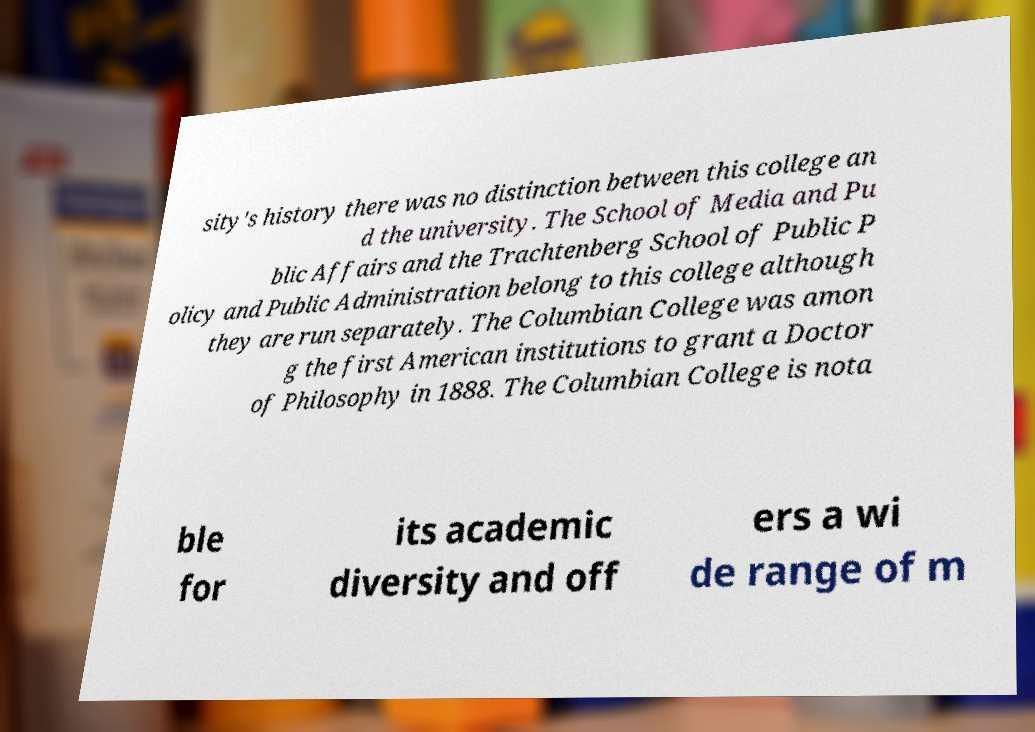What messages or text are displayed in this image? I need them in a readable, typed format. sity's history there was no distinction between this college an d the university. The School of Media and Pu blic Affairs and the Trachtenberg School of Public P olicy and Public Administration belong to this college although they are run separately. The Columbian College was amon g the first American institutions to grant a Doctor of Philosophy in 1888. The Columbian College is nota ble for its academic diversity and off ers a wi de range of m 